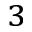<formula> <loc_0><loc_0><loc_500><loc_500>^ { 3 }</formula> 